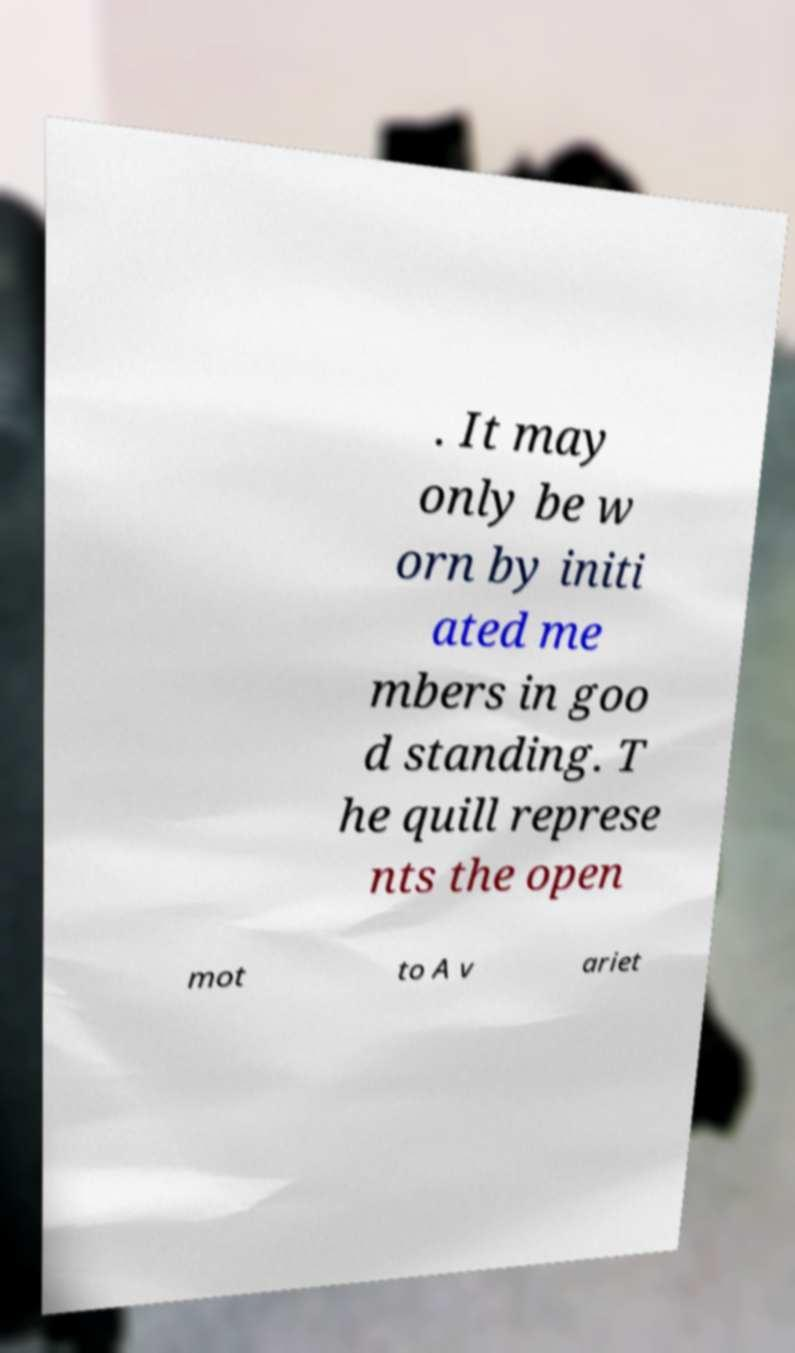I need the written content from this picture converted into text. Can you do that? . It may only be w orn by initi ated me mbers in goo d standing. T he quill represe nts the open mot to A v ariet 